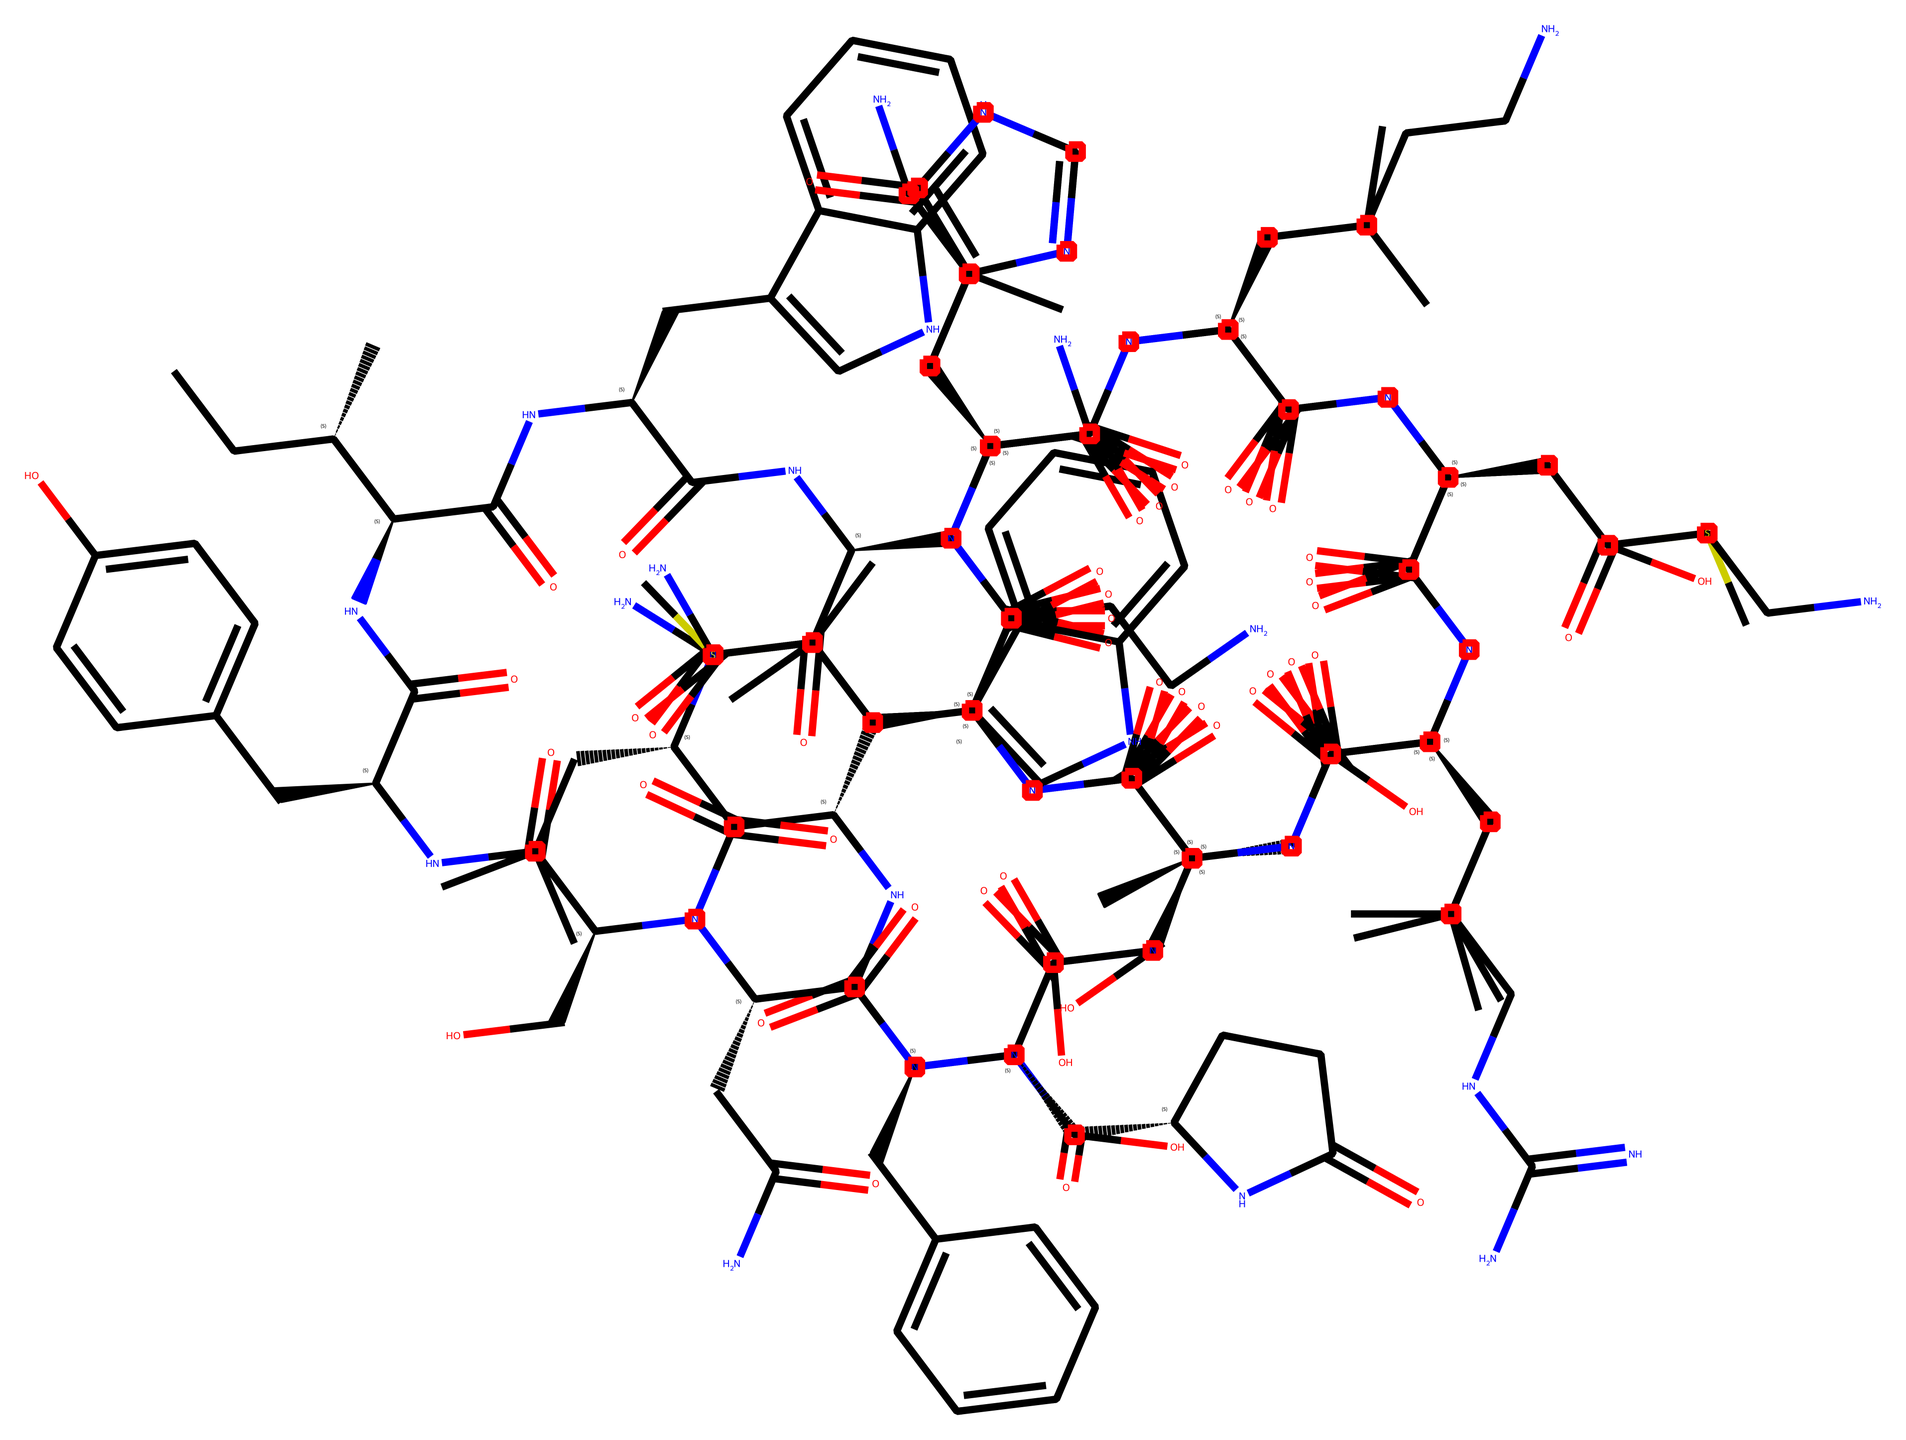What is the primary functional group in this chemical? The presence of multiple amide (-C(=O)N-) groups indicates that this chemical contains several amide functional groups. Observing the molecular structure, we can see the distinct -C(=O)N- linkages that repeat throughout, which is characteristic of an amide.
Answer: amide How many carbon atoms are in this chemical? To determine the number of carbon atoms, we can visually count each distinct carbon represented in the chemical structure. Upon careful examination, a total of 41 carbon atoms can be identified from the structure.
Answer: 41 What type of chemical is this? Given its structure and the presence of various nitrogen and carbon functional groups, this chemical is classified as a peptide hormone. Peptide hormones are typically composed of amino acids, and this structure reflects the characteristics of such compounds.
Answer: peptide hormone How many amine groups are present in this chemical? By analyzing the structure, we can identify the presence of multiple amine functional groups (-NH2). Each amine group contributes to the overall structure of the hormone, and careful examination reveals the occurrence of 6 amine groups.
Answer: 6 Which part of the chemical structure is responsible for pain relief? The chemical arrangement of endorphins is closely linked to their function as natural pain relievers. The specific arrangement of amide and aromatic groups correlates with their affinity for opioid receptors, contributing to the pain-relief properties.
Answer: opioid receptors What is the molecular weight of this chemical approximately? While specific calculations from the provided SMILES representation require computational tools, generally, peptide hormones of this length can have a molecular weight around 1000-1500 daltons. However, for precise weight, a detailed molecular calculation would be needed.
Answer: around 1000-1500 daltons 